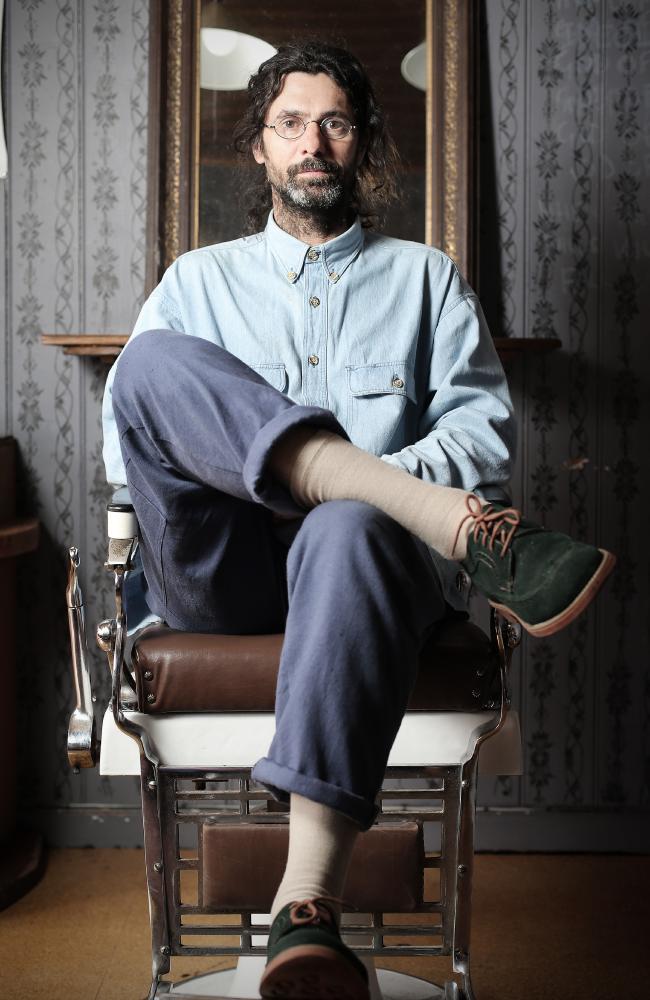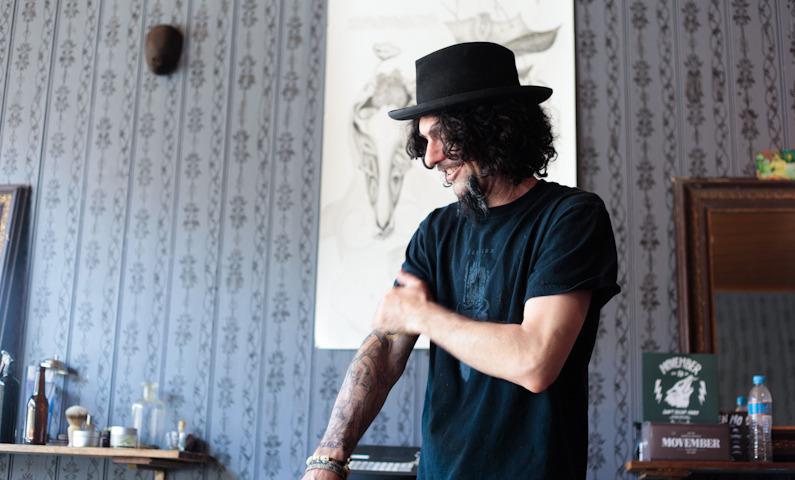The first image is the image on the left, the second image is the image on the right. Considering the images on both sides, is "A forward-facing man who is not a customer sits on a barber chair in the center of one scene." valid? Answer yes or no. Yes. 